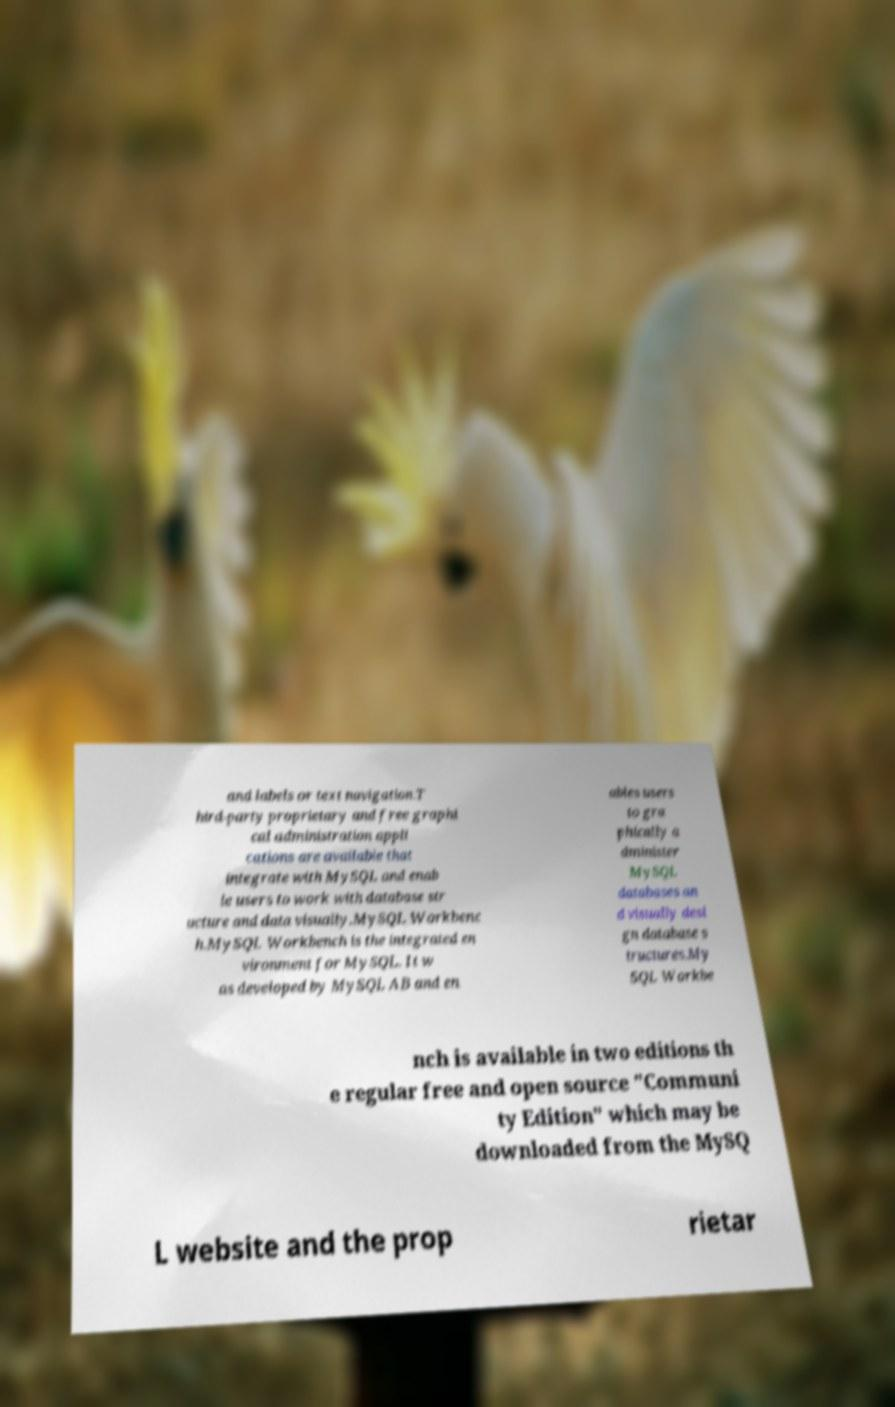Please identify and transcribe the text found in this image. and labels or text navigation.T hird-party proprietary and free graphi cal administration appli cations are available that integrate with MySQL and enab le users to work with database str ucture and data visually.MySQL Workbenc h.MySQL Workbench is the integrated en vironment for MySQL. It w as developed by MySQL AB and en ables users to gra phically a dminister MySQL databases an d visually desi gn database s tructures.My SQL Workbe nch is available in two editions th e regular free and open source "Communi ty Edition" which may be downloaded from the MySQ L website and the prop rietar 